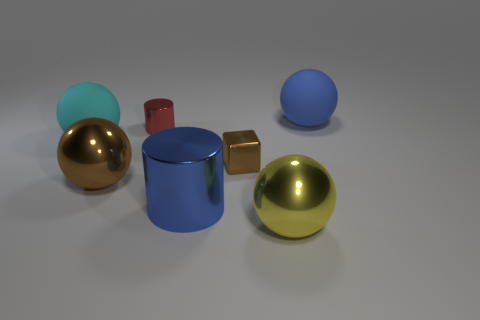Subtract all cyan matte balls. How many balls are left? 3 Add 2 rubber things. How many objects exist? 9 Subtract all cyan spheres. How many spheres are left? 3 Subtract all spheres. How many objects are left? 3 Subtract 3 balls. How many balls are left? 1 Subtract all green cylinders. Subtract all green cubes. How many cylinders are left? 2 Subtract all purple things. Subtract all yellow metallic things. How many objects are left? 6 Add 5 large blue spheres. How many large blue spheres are left? 6 Add 4 large cyan matte balls. How many large cyan matte balls exist? 5 Subtract 0 red blocks. How many objects are left? 7 